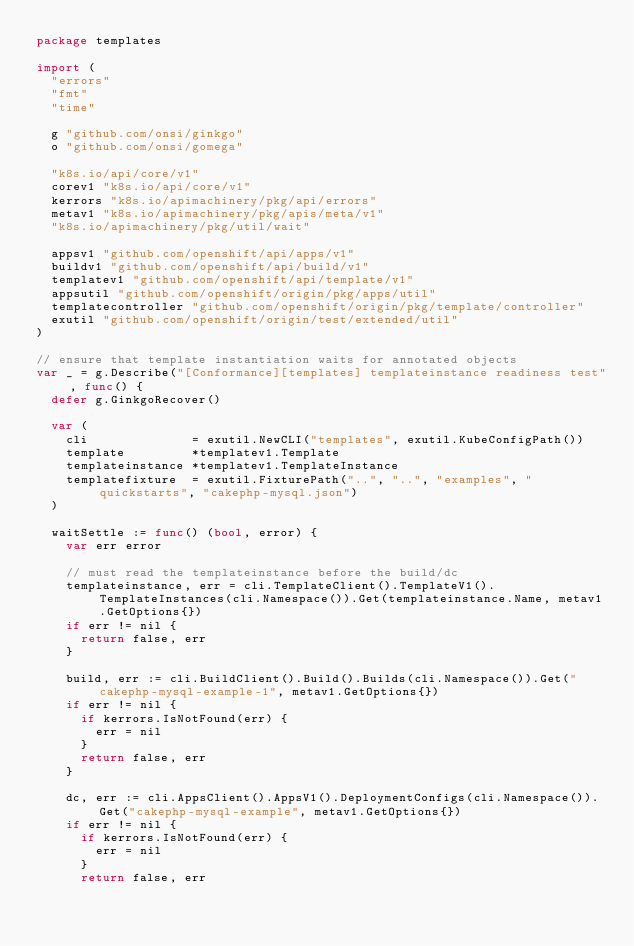<code> <loc_0><loc_0><loc_500><loc_500><_Go_>package templates

import (
	"errors"
	"fmt"
	"time"

	g "github.com/onsi/ginkgo"
	o "github.com/onsi/gomega"

	"k8s.io/api/core/v1"
	corev1 "k8s.io/api/core/v1"
	kerrors "k8s.io/apimachinery/pkg/api/errors"
	metav1 "k8s.io/apimachinery/pkg/apis/meta/v1"
	"k8s.io/apimachinery/pkg/util/wait"

	appsv1 "github.com/openshift/api/apps/v1"
	buildv1 "github.com/openshift/api/build/v1"
	templatev1 "github.com/openshift/api/template/v1"
	appsutil "github.com/openshift/origin/pkg/apps/util"
	templatecontroller "github.com/openshift/origin/pkg/template/controller"
	exutil "github.com/openshift/origin/test/extended/util"
)

// ensure that template instantiation waits for annotated objects
var _ = g.Describe("[Conformance][templates] templateinstance readiness test", func() {
	defer g.GinkgoRecover()

	var (
		cli              = exutil.NewCLI("templates", exutil.KubeConfigPath())
		template         *templatev1.Template
		templateinstance *templatev1.TemplateInstance
		templatefixture  = exutil.FixturePath("..", "..", "examples", "quickstarts", "cakephp-mysql.json")
	)

	waitSettle := func() (bool, error) {
		var err error

		// must read the templateinstance before the build/dc
		templateinstance, err = cli.TemplateClient().TemplateV1().TemplateInstances(cli.Namespace()).Get(templateinstance.Name, metav1.GetOptions{})
		if err != nil {
			return false, err
		}

		build, err := cli.BuildClient().Build().Builds(cli.Namespace()).Get("cakephp-mysql-example-1", metav1.GetOptions{})
		if err != nil {
			if kerrors.IsNotFound(err) {
				err = nil
			}
			return false, err
		}

		dc, err := cli.AppsClient().AppsV1().DeploymentConfigs(cli.Namespace()).Get("cakephp-mysql-example", metav1.GetOptions{})
		if err != nil {
			if kerrors.IsNotFound(err) {
				err = nil
			}
			return false, err</code> 